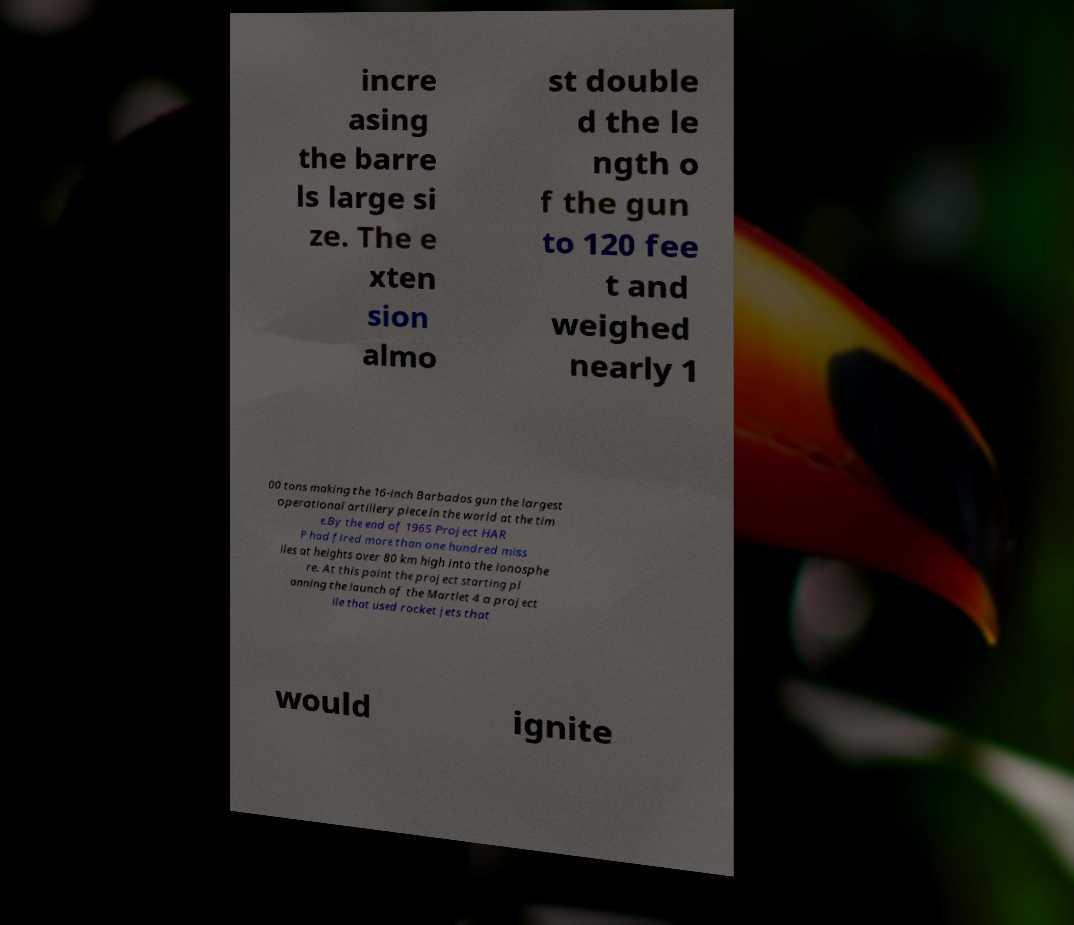There's text embedded in this image that I need extracted. Can you transcribe it verbatim? incre asing the barre ls large si ze. The e xten sion almo st double d the le ngth o f the gun to 120 fee t and weighed nearly 1 00 tons making the 16-inch Barbados gun the largest operational artillery piece in the world at the tim e.By the end of 1965 Project HAR P had fired more than one hundred miss iles at heights over 80 km high into the ionosphe re. At this point the project starting pl anning the launch of the Martlet 4 a project ile that used rocket jets that would ignite 